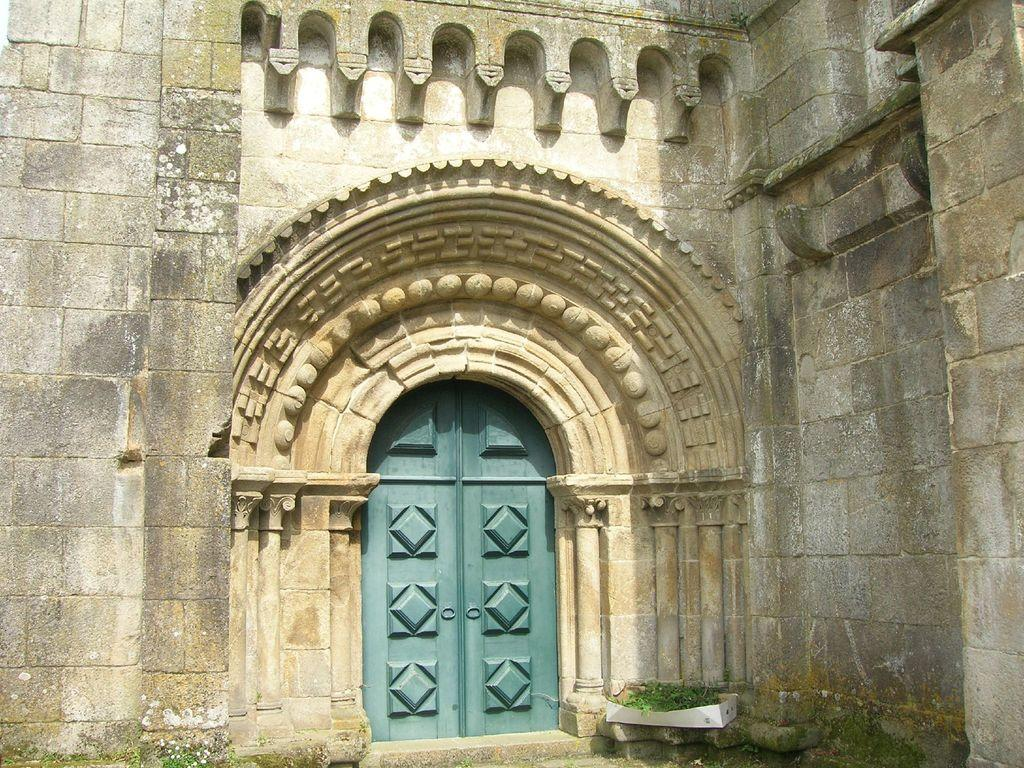What is the main subject of the image? The main subject of the image is a building. Can you describe any specific features of the building? There is a door in the middle of the image. What type of attraction can be seen in the image? There is no attraction present in the image; it is a building with a door. How many trees are visible in the image? There are no trees visible in the image. 